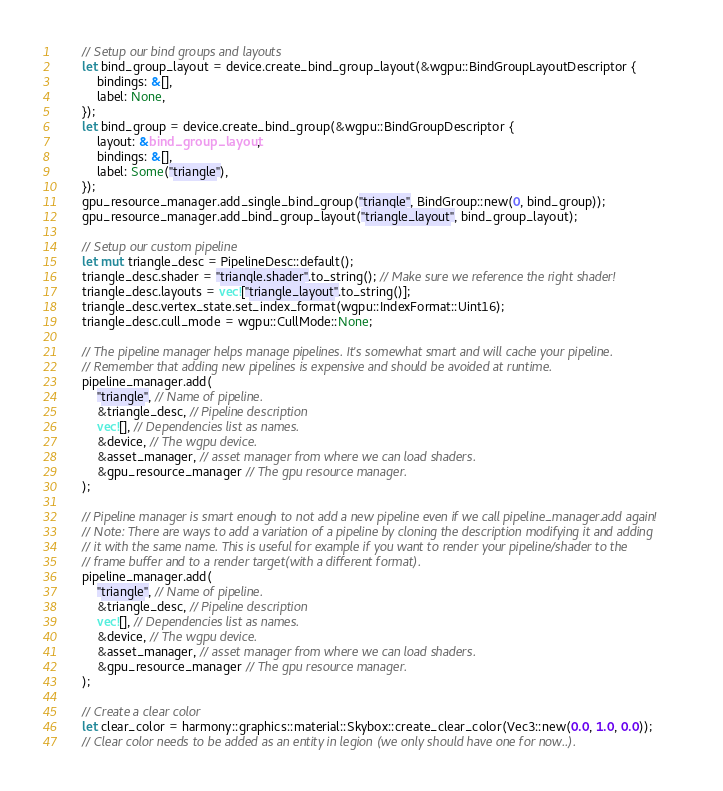Convert code to text. <code><loc_0><loc_0><loc_500><loc_500><_Rust_>        // Setup our bind groups and layouts
        let bind_group_layout = device.create_bind_group_layout(&wgpu::BindGroupLayoutDescriptor {
            bindings: &[],
            label: None,
        });
        let bind_group = device.create_bind_group(&wgpu::BindGroupDescriptor {
            layout: &bind_group_layout,
            bindings: &[],
            label: Some("triangle"),
        });
        gpu_resource_manager.add_single_bind_group("triangle", BindGroup::new(0, bind_group));
        gpu_resource_manager.add_bind_group_layout("triangle_layout", bind_group_layout);

        // Setup our custom pipeline
        let mut triangle_desc = PipelineDesc::default();
        triangle_desc.shader = "triangle.shader".to_string(); // Make sure we reference the right shader!
        triangle_desc.layouts = vec!["triangle_layout".to_string()];
        triangle_desc.vertex_state.set_index_format(wgpu::IndexFormat::Uint16);
        triangle_desc.cull_mode = wgpu::CullMode::None;

        // The pipeline manager helps manage pipelines. It's somewhat smart and will cache your pipeline.
        // Remember that adding new pipelines is expensive and should be avoided at runtime.
        pipeline_manager.add(
            "triangle", // Name of pipeline.
            &triangle_desc, // Pipeline description
            vec![], // Dependencies list as names.
            &device, // The wgpu device.
            &asset_manager, // asset manager from where we can load shaders.
            &gpu_resource_manager // The gpu resource manager.
        );
        
        // Pipeline manager is smart enough to not add a new pipeline even if we call pipeline_manager.add again!
        // Note: There are ways to add a variation of a pipeline by cloning the description modifying it and adding
        // it with the same name. This is useful for example if you want to render your pipeline/shader to the 
        // frame buffer and to a render target(with a different format).
        pipeline_manager.add(
            "triangle", // Name of pipeline.
            &triangle_desc, // Pipeline description
            vec![], // Dependencies list as names.
            &device, // The wgpu device.
            &asset_manager, // asset manager from where we can load shaders.
            &gpu_resource_manager // The gpu resource manager.
        );

        // Create a clear color
        let clear_color = harmony::graphics::material::Skybox::create_clear_color(Vec3::new(0.0, 1.0, 0.0));
        // Clear color needs to be added as an entity in legion (we only should have one for now..).</code> 